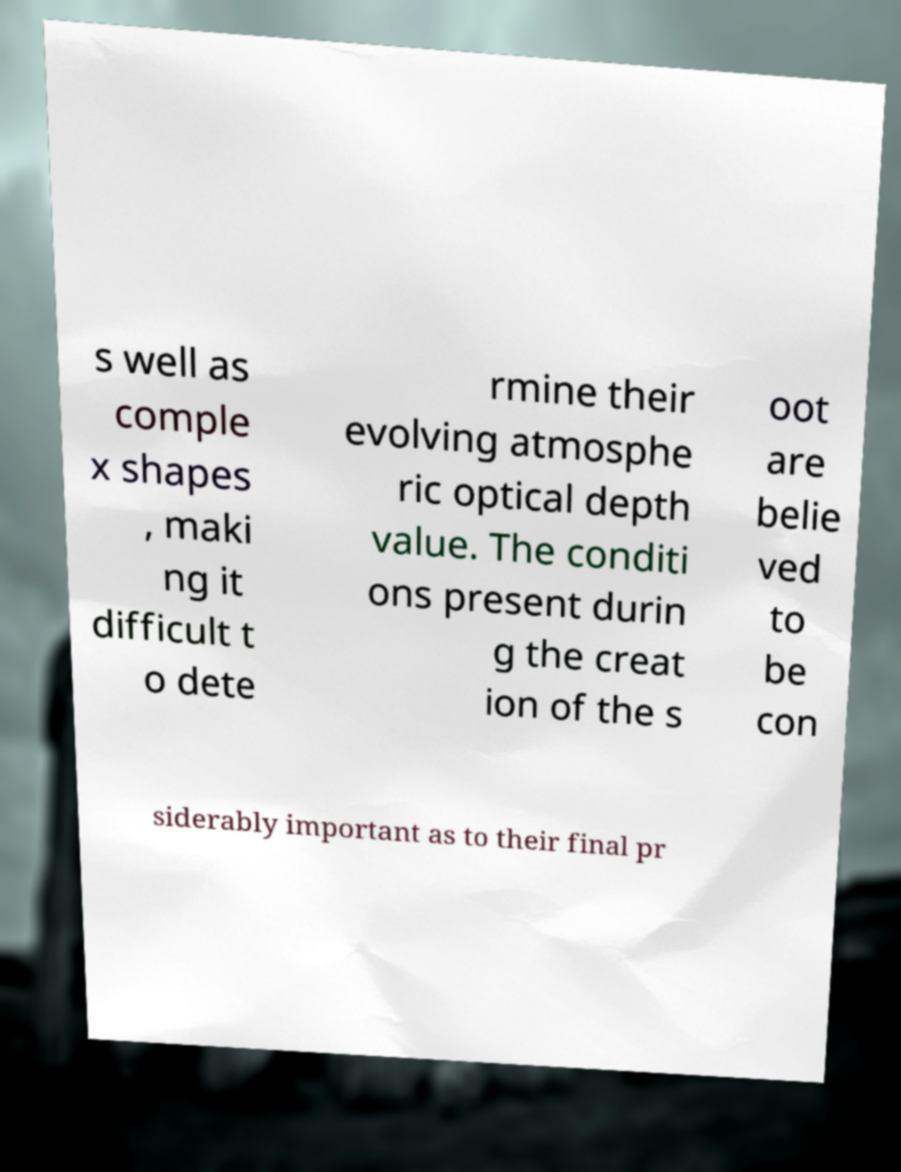Please identify and transcribe the text found in this image. s well as comple x shapes , maki ng it difficult t o dete rmine their evolving atmosphe ric optical depth value. The conditi ons present durin g the creat ion of the s oot are belie ved to be con siderably important as to their final pr 